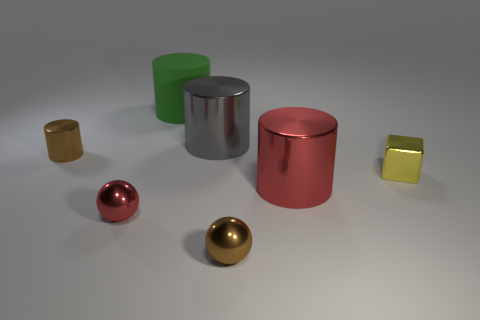Subtract 1 cylinders. How many cylinders are left? 3 Add 2 small red shiny things. How many objects exist? 9 Subtract all blocks. How many objects are left? 6 Subtract all large yellow rubber spheres. Subtract all tiny metal spheres. How many objects are left? 5 Add 6 small cylinders. How many small cylinders are left? 7 Add 6 small brown metallic balls. How many small brown metallic balls exist? 7 Subtract 0 blue balls. How many objects are left? 7 